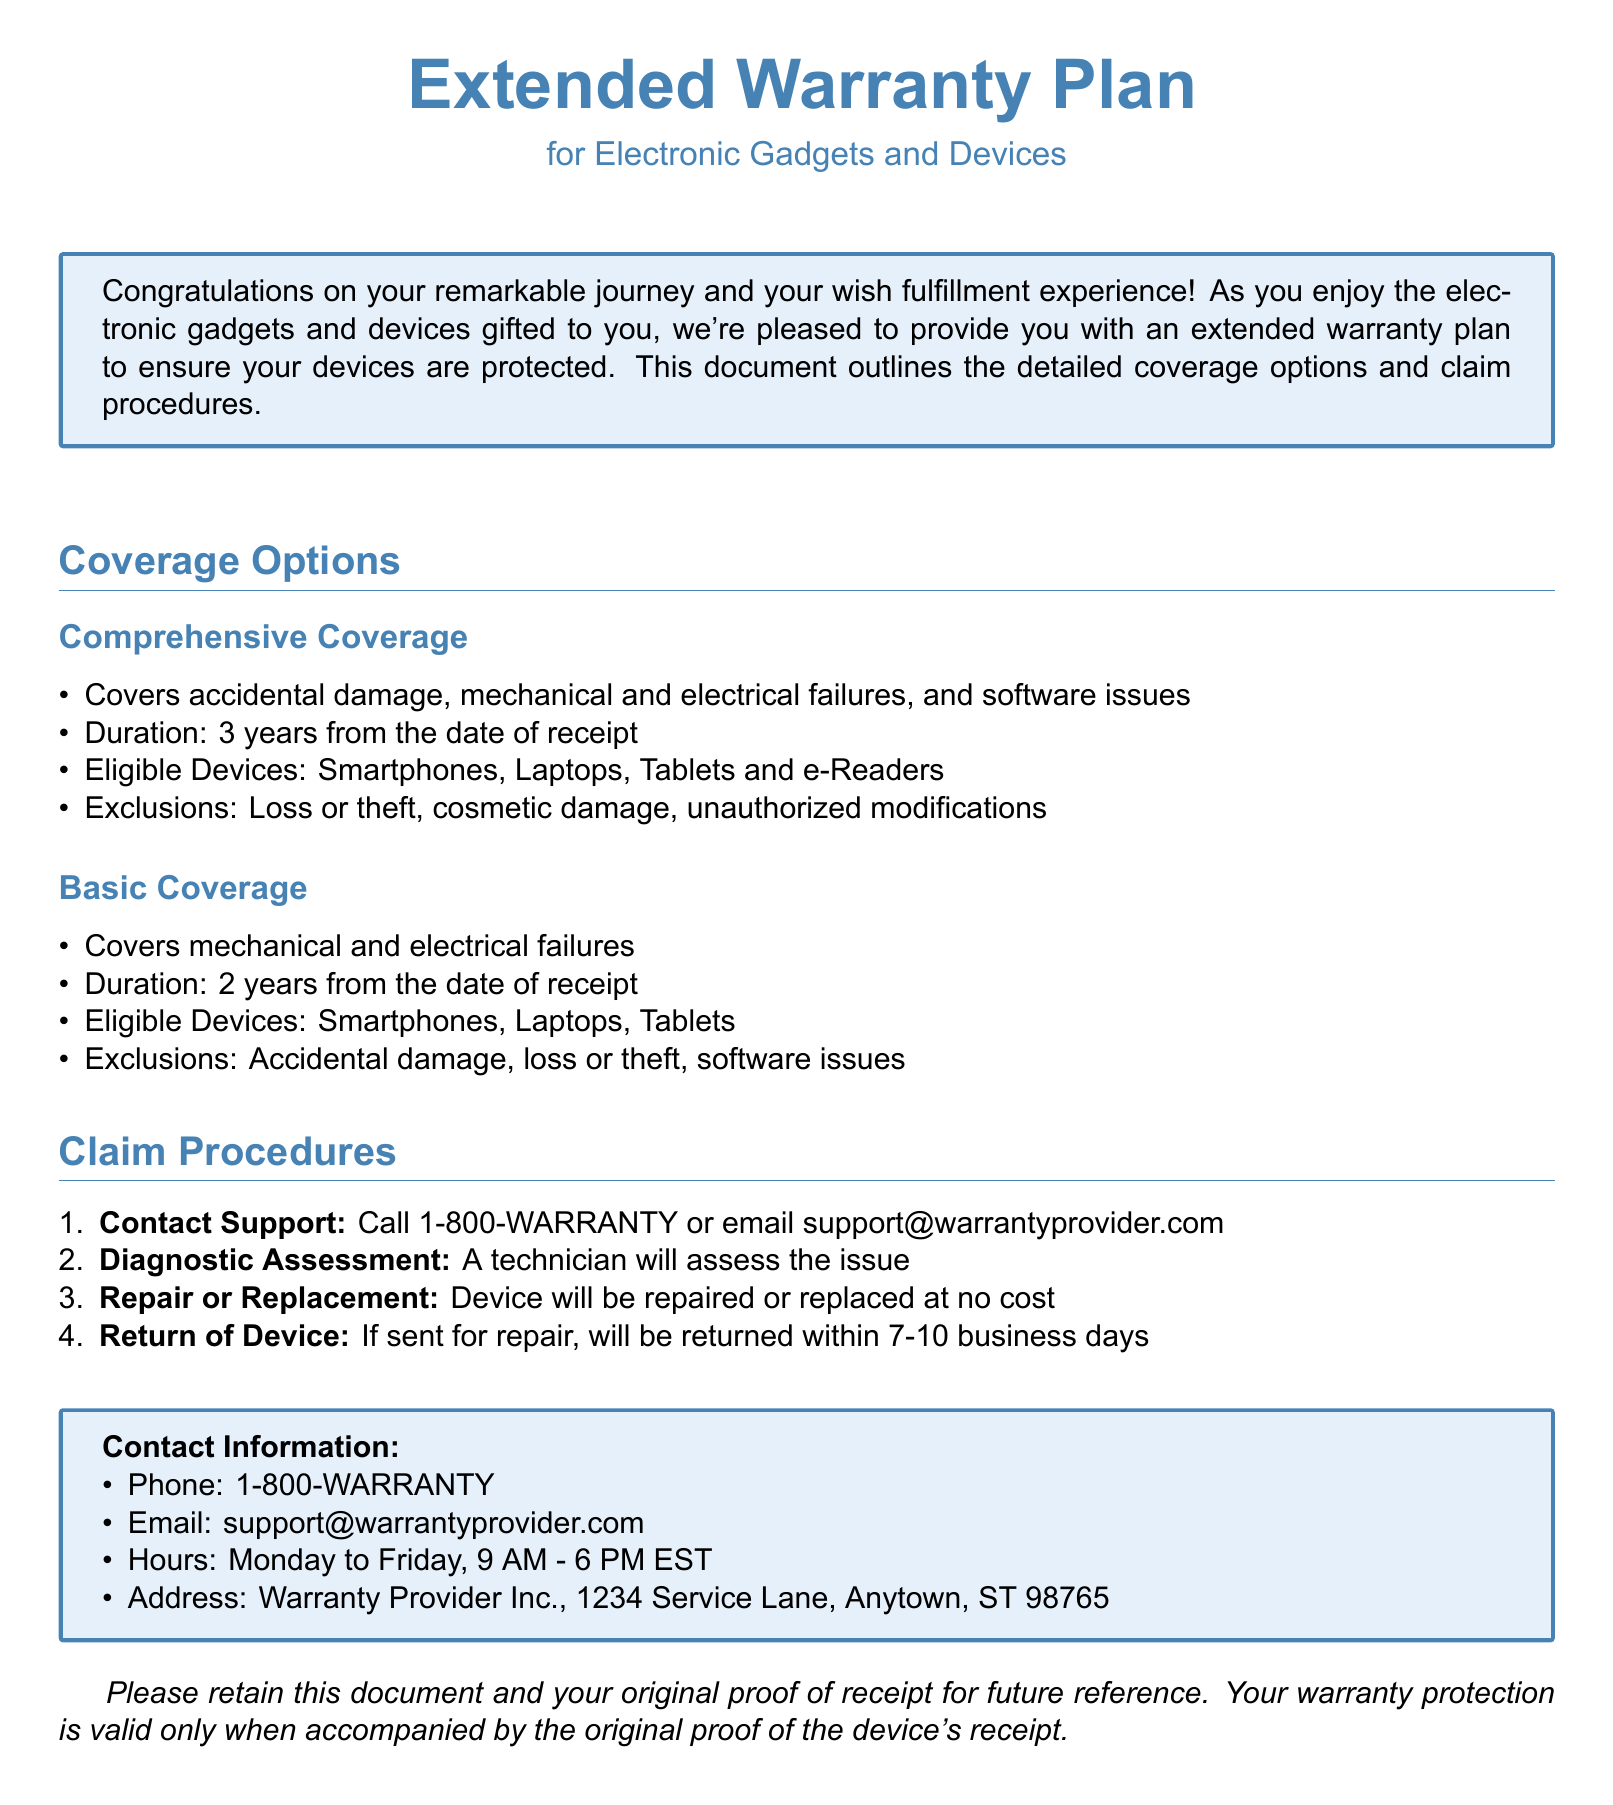What is the duration of the Comprehensive Coverage? The Comprehensive Coverage lasts for 3 years from the date of receipt.
Answer: 3 years What type of devices are eligible for Basic Coverage? Basic Coverage is eligible for Smartphones, Laptops, and Tablets.
Answer: Smartphones, Laptops, Tablets What is excluded from the Comprehensive Coverage? The Comprehensive Coverage excludes loss or theft, cosmetic damage, and unauthorized modifications.
Answer: Loss or theft, cosmetic damage, unauthorized modifications What is the contact number for support? The document provides the contact number as 1-800-WARRANTY.
Answer: 1-800-WARRANTY How long will the device be returned after repair? Devices sent for repair will be returned within 7-10 business days.
Answer: 7-10 business days What is covered under Basic Coverage? Basic Coverage covers mechanical and electrical failures.
Answer: Mechanical and electrical failures What is the email address for warranty support? The email address provided in the document for support is support@warrantyprovider.com.
Answer: support@warrantyprovider.com What are the business hours for contacting support? The business hours are Monday to Friday, 9 AM - 6 PM EST.
Answer: Monday to Friday, 9 AM - 6 PM EST What type of document is this? This document is a warranty plan for electronic gadgets and devices.
Answer: Warranty plan 